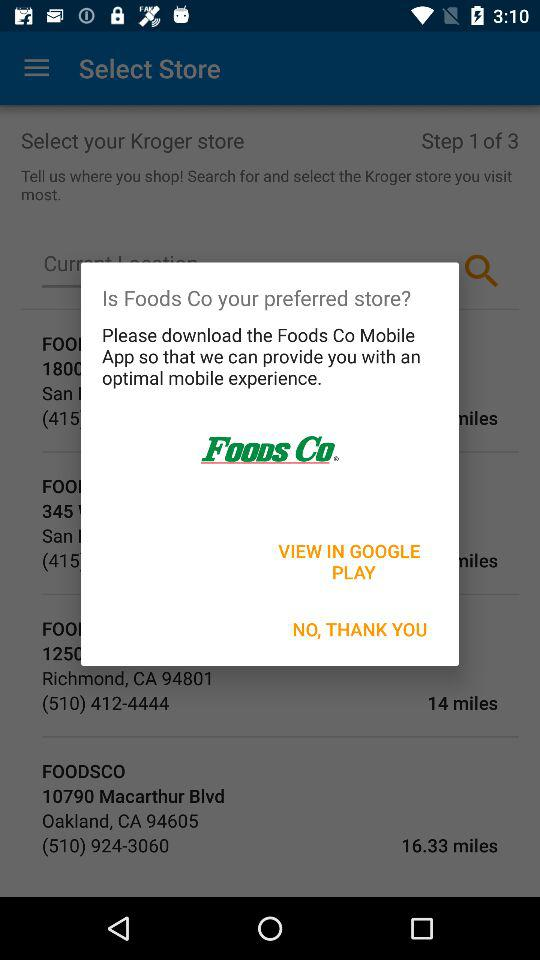How far is the "FOODSCO" store located in Oakland? It is 16.33 miles away. 